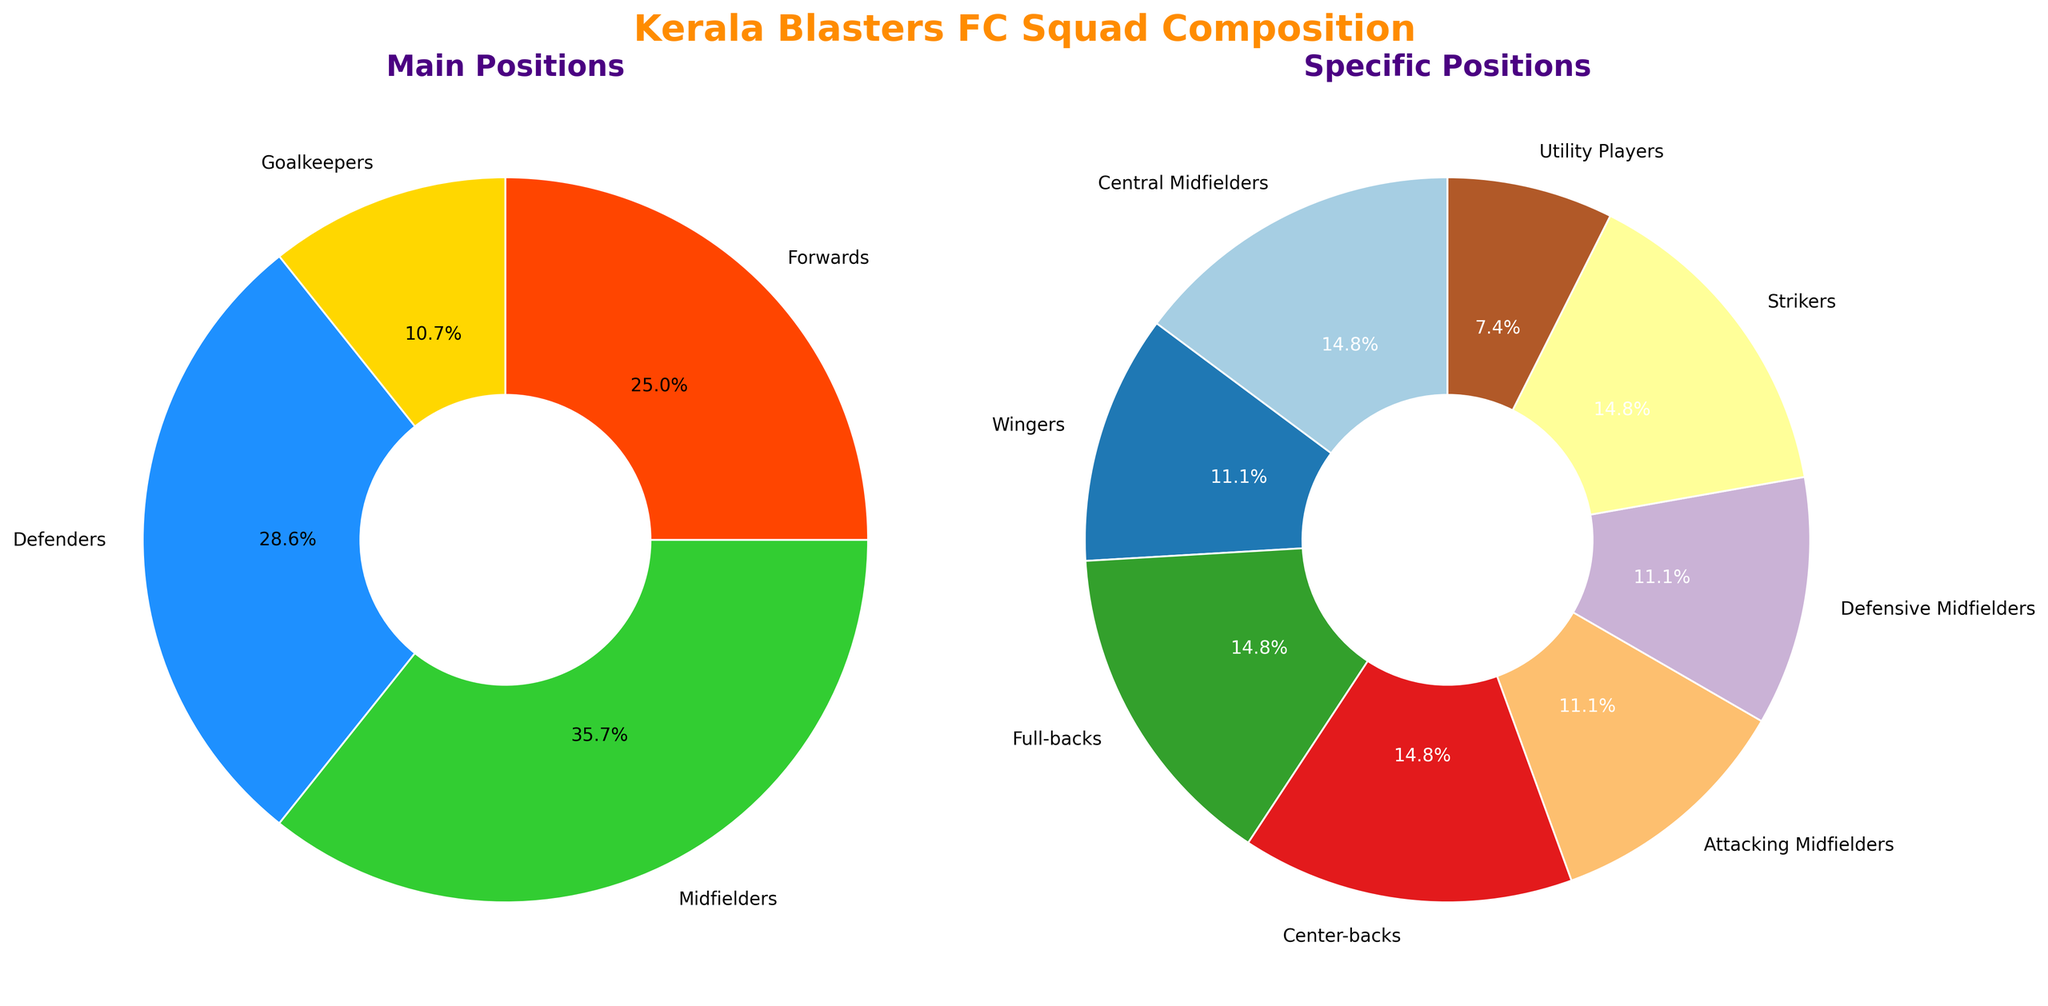What's the largest group in the main positions pie chart? Look at the first pie chart titled "Main Positions." The slice labeled "Midfielders" appears the largest.
Answer: Midfielders How many players are there in the attacking roles combined (Forwards and Attacking Midfielders)? In the second pie chart, find "Forwards" and "Attacking Midfielders" and sum their counts (7 from Forwards and 3 from Attacking Midfielders). The total is 7 + 3 = 10.
Answer: 10 Which position group occupies the smallest portion in the specific positions pie chart? Look at the second pie chart titled "Specific Positions." The smallest slice is labeled "Utility Players."
Answer: Utility Players What's the percentage of Goalkeepers in the main positions? In the first pie chart, the slice labeled "Goalkeepers" represents 3 out of the total 28 players (sum of main positions). Calculate: (3/28) * 100 = 10.7%.
Answer: 10.7% Compare the number of players in Central Midfielders and Defensive Midfielders. Which group is larger? Look at the second pie chart for "Central Midfielders" (4 players) and "Defensive Midfielders" (3 players). "Central Midfielders" has more players.
Answer: Central Midfielders If you combine Full-backs and Wingers, how many players are there in total? In the second pie chart, sum the counts for "Full-backs" (4 players) and "Wingers" (3 players). The combined total is 4 + 3 = 7.
Answer: 7 What is the ratio of Defenders to Midfielders in the main positions? In the first pie chart, "Defenders" has 8 players and "Midfielders" has 10. The ratio of Defenders to Midfielders is 8:10, which simplifies to 4:5.
Answer: 4:5 Are there more Strikers or Center-backs in the squad? In the second pie chart, compare "Strikers" (4 players) and "Center-backs" (4 players). Both groups have the same number of players.
Answer: Equal What percentage of the specific positions is made up by Strikers? In the second pie chart, the percentage for "Strikers" is given directly on the slice, which is 12.1%.
Answer: 12.1% How does the proportion of Full-backs compare to that of Wingers in terms of percentage? In the second pie chart, look at the percentages for "Full-backs" and "Wingers." If Full-backs are 16.1% and Wingers are 12.1%, Full-backs have a higher percentage.
Answer: Full-backs have a higher percentage 